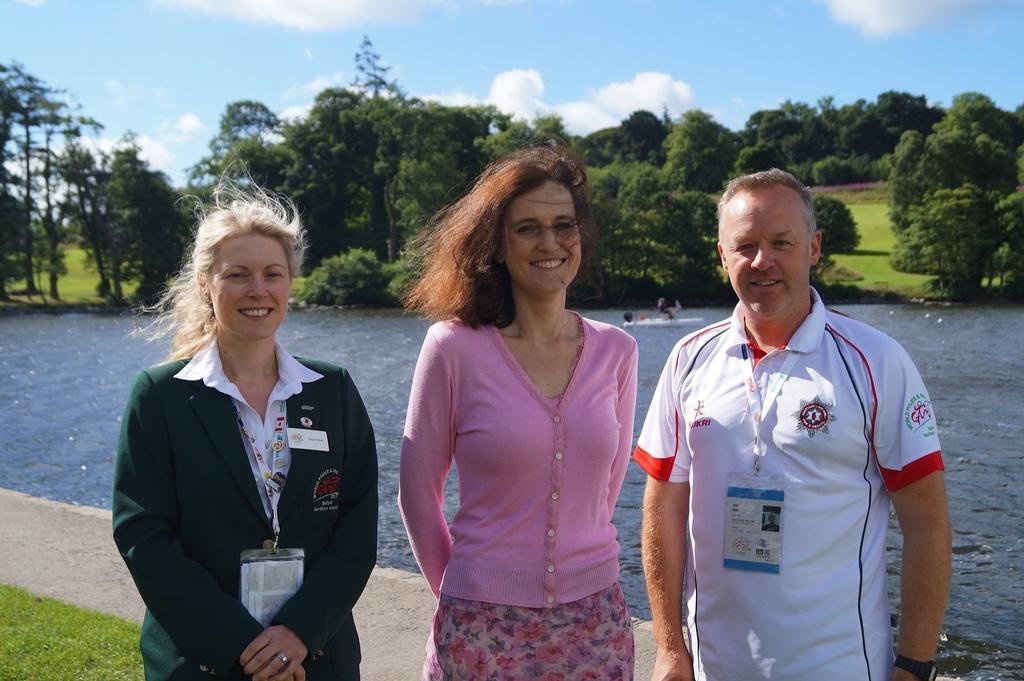Please provide a concise description of this image. In this image on the right there is a man, he wears a t shirt, tag. In the middle there is a woman, she wears a sweater. On the left there is a woman, she wears a suit, shirt, tag, she is smiling. At the bottom there is grass. In the background there are trees, water, boat, grass, sky and clouds. 